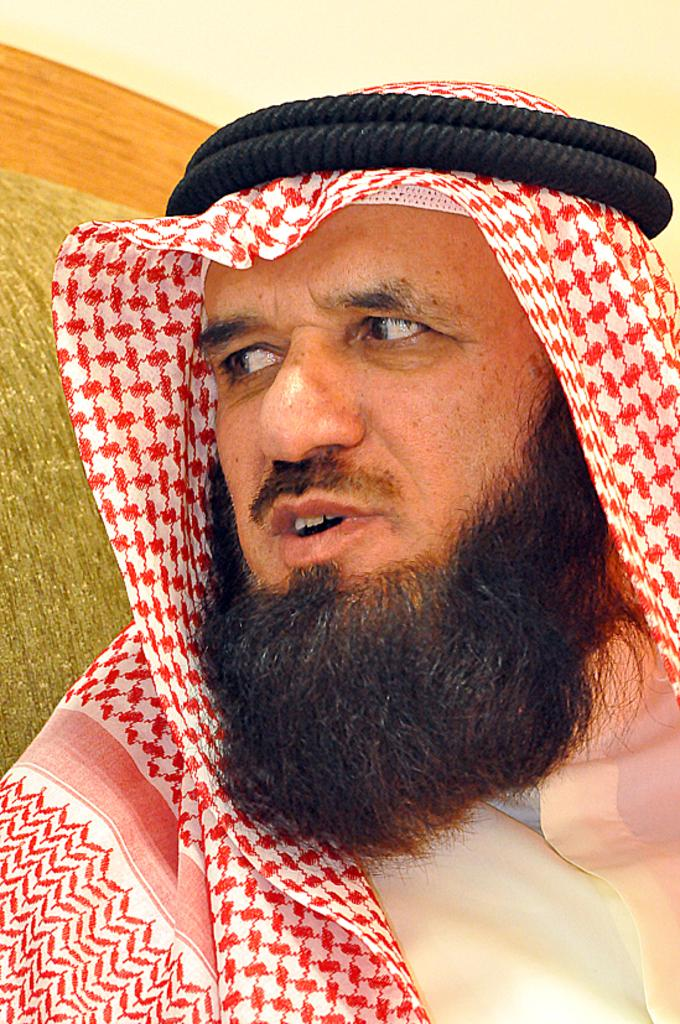Who or what is the main subject in the image? There is a person in the center of the image. What can be seen in the background of the image? There is a wall in the background of the image. How many ants are crawling on the person's shirt in the image? There are no ants visible on the person's shirt in the image. What type of work is the person doing in the image? The image does not provide any information about the person's work or activity. 